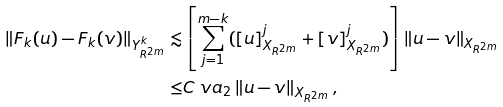<formula> <loc_0><loc_0><loc_500><loc_500>\left \| F _ { k } ( u ) - F _ { k } ( v ) \right \| _ { Y ^ { k } _ { R ^ { 2 m } } } \lesssim & \left [ \sum _ { j = 1 } ^ { m - k } ( [ u ] _ { X _ { R ^ { 2 m } } } ^ { j } + [ v ] _ { X _ { R ^ { 2 m } } } ^ { j } ) \right ] \left \| u - v \right \| _ { X _ { R ^ { 2 m } } } \\ \leq & C \ v a _ { 2 } \left \| u - v \right \| _ { X _ { R ^ { 2 m } } } ,</formula> 